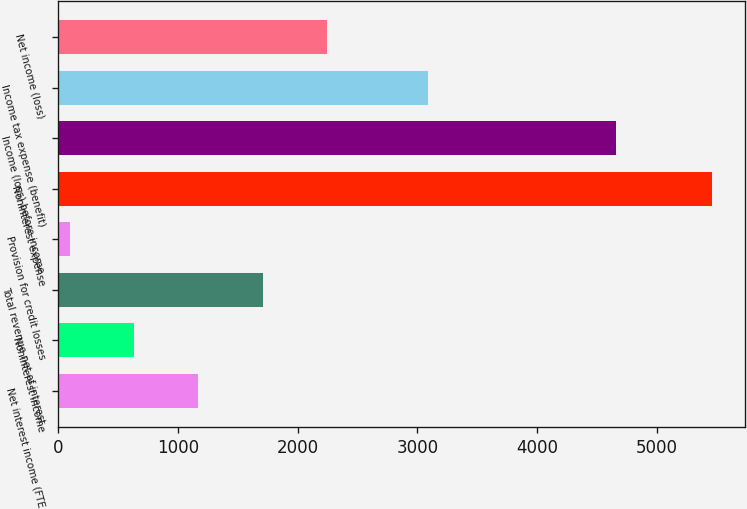Convert chart. <chart><loc_0><loc_0><loc_500><loc_500><bar_chart><fcel>Net interest income (FTE<fcel>Noninterest income<fcel>Total revenue net of interest<fcel>Provision for credit losses<fcel>Noninterest expense<fcel>Income (loss) before income<fcel>Income tax expense (benefit)<fcel>Net income (loss)<nl><fcel>1172<fcel>636<fcel>1708<fcel>100<fcel>5460<fcel>4660<fcel>3085<fcel>2244<nl></chart> 